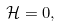Convert formula to latex. <formula><loc_0><loc_0><loc_500><loc_500>\mathcal { H } = 0 ,</formula> 